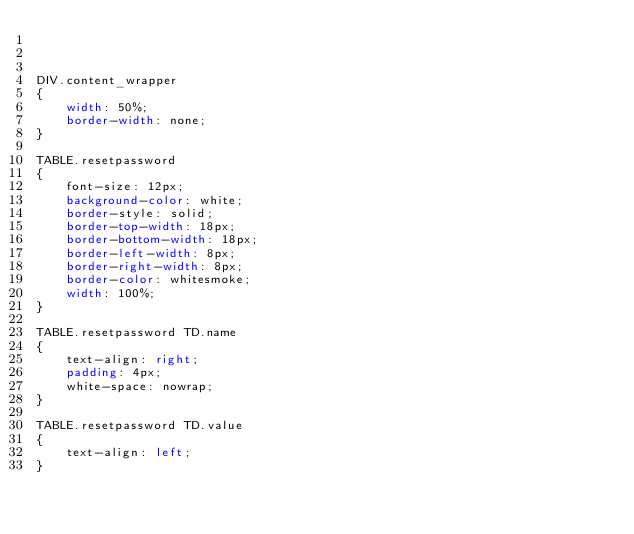<code> <loc_0><loc_0><loc_500><loc_500><_CSS_>


DIV.content_wrapper
{
	width: 50%;
	border-width: none;
}

TABLE.resetpassword
{
	font-size: 12px;
	background-color: white;
	border-style: solid;
	border-top-width: 18px;
	border-bottom-width: 18px;
	border-left-width: 8px;
	border-right-width: 8px;
	border-color: whitesmoke;
	width: 100%;
}

TABLE.resetpassword TD.name
{
	text-align: right;
	padding: 4px;
	white-space: nowrap;
}

TABLE.resetpassword TD.value
{
	text-align: left;
}
</code> 